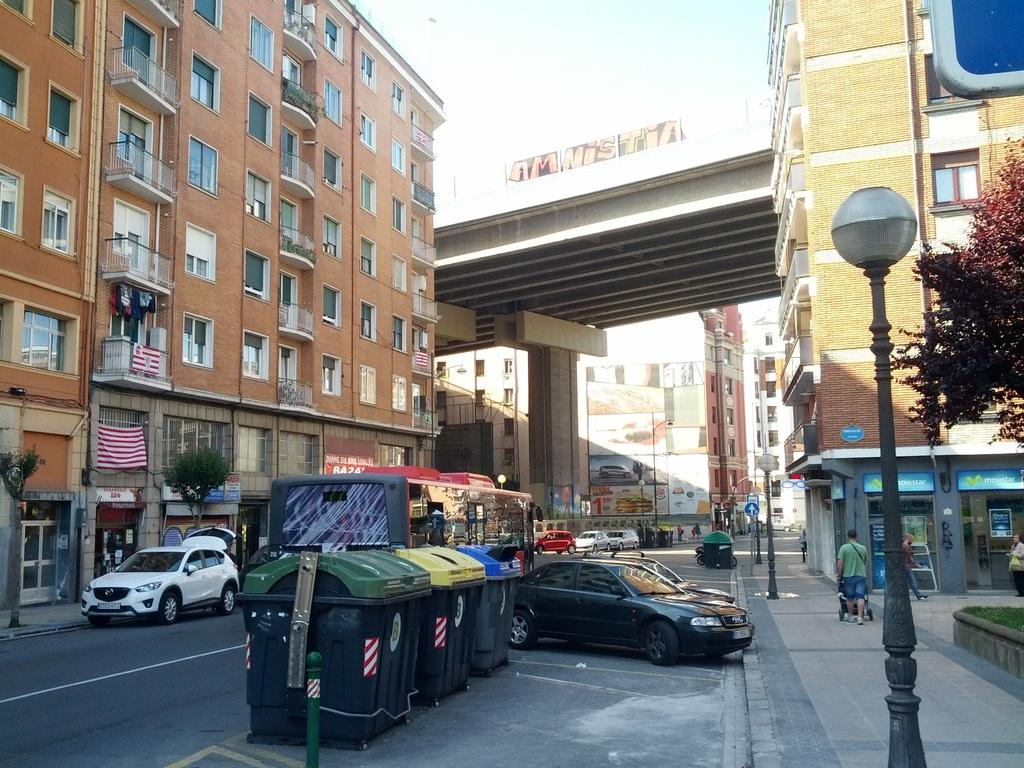What type of containers are present in the image? There are dustbins in the image. What can be seen on the road in the image? There are vehicles on the road in the image. What structures are located beside the road in the image? There are buildings beside the road in the image. What type of plant is visible in the image? There is a tree in the image. What type of pole is present in the image? There is a street light pole in the image. What type of belief is depicted in the image? There is no depiction of a belief in the image; it features dustbins, vehicles, buildings, a tree, and a street light pole. Can you tell me how many rats are visible in the image? There are no rats present in the image. 